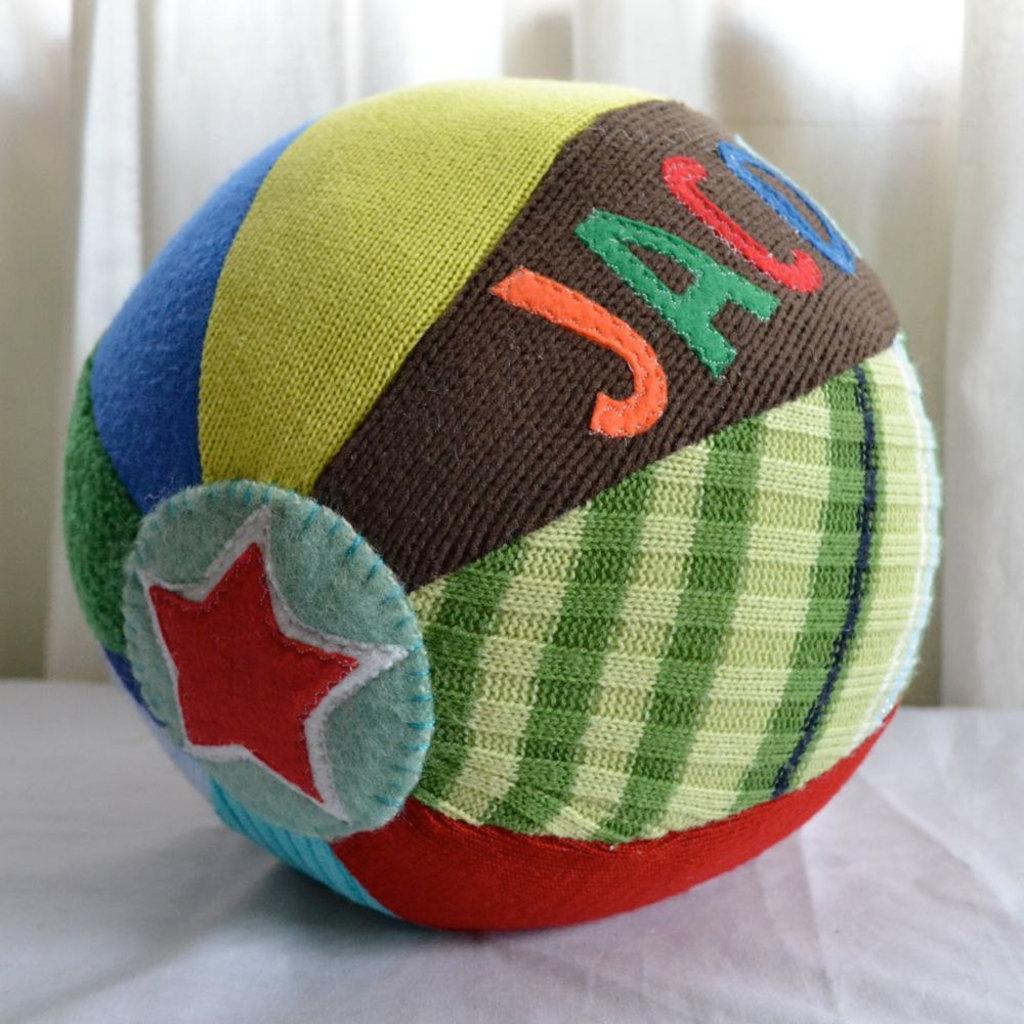Could you give a brief overview of what you see in this image? In this image in the center there is one ball and at the bottom it looks like a table, and in the background there is a curtain. 